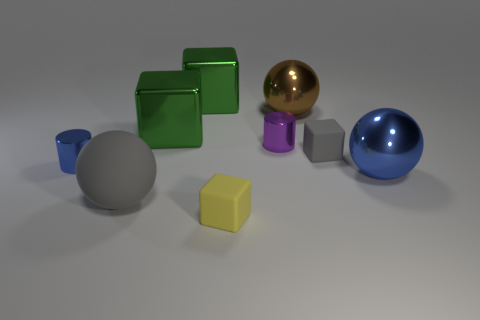Subtract all small yellow matte cubes. How many cubes are left? 3 Subtract all green cubes. How many cubes are left? 2 Subtract 0 blue blocks. How many objects are left? 9 Subtract all cylinders. How many objects are left? 7 Subtract 1 spheres. How many spheres are left? 2 Subtract all blue balls. Subtract all yellow cubes. How many balls are left? 2 Subtract all purple blocks. How many blue spheres are left? 1 Subtract all green shiny things. Subtract all blue metal spheres. How many objects are left? 6 Add 2 big green metallic things. How many big green metallic things are left? 4 Add 3 large blue metallic things. How many large blue metallic things exist? 4 